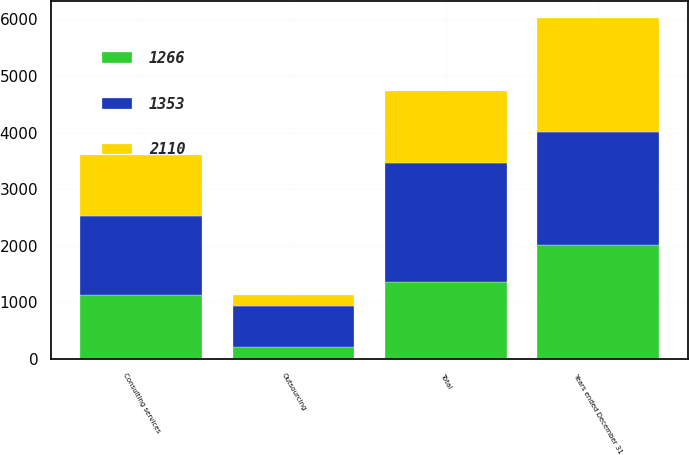<chart> <loc_0><loc_0><loc_500><loc_500><stacked_bar_chart><ecel><fcel>Years ended December 31<fcel>Consulting services<fcel>Outsourcing<fcel>Total<nl><fcel>1353<fcel>2010<fcel>1387<fcel>731<fcel>2110<nl><fcel>2110<fcel>2009<fcel>1075<fcel>191<fcel>1266<nl><fcel>1266<fcel>2008<fcel>1139<fcel>214<fcel>1353<nl></chart> 